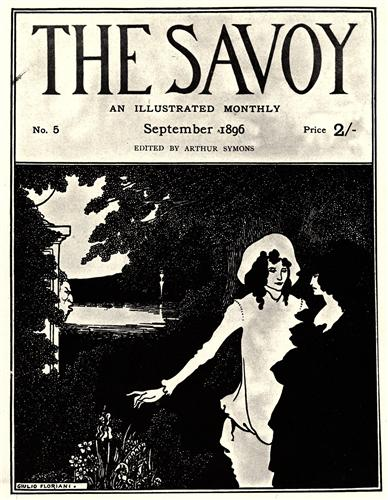Can you describe the significance of the Art Nouveau style in this image? Art Nouveau, a distinctive artistic style that flourished between 1890 and 1910, is characterized by its intricate linear designs and flowing curves inspired by natural forms. In this image, the Art Nouveau influence is evident in the elegant contours and organic motifs that enhance the overall aesthetic. The style adds a sense of dynamism and elegance to the cover, creating an immersive visual experience. By incorporating elements like the flowing river, the delicate features of the garden, and the fluid form of the characters, the artist brings a harmonious and sophisticated quality to the illustration, reflecting the essence of Art Nouveau’s emphasis on beauty and harmony in art and design. What kind of emotional response do you think the image evokes? The image likely evokes a serene and nostalgic emotional response. The peaceful garden setting, combined with the tender interaction between the figures, conjures feelings of tranquility, romance, and a longing for simpler, bygone days. The monochromatic palette and the timeless elegance of the Art Nouveau style further reinforce the sense of calmness and introspection, inviting viewers to immerse themselves in a reflective state of mind. 